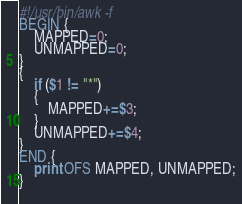<code> <loc_0><loc_0><loc_500><loc_500><_Awk_>#!/usr/bin/awk -f
BEGIN {
    MAPPED=0;
    UNMAPPED=0;
}
{
    if ($1 != "*")
    {
        MAPPED+=$3;
    }
    UNMAPPED+=$4;
}
END {
    print OFS MAPPED, UNMAPPED;
}
        
</code> 